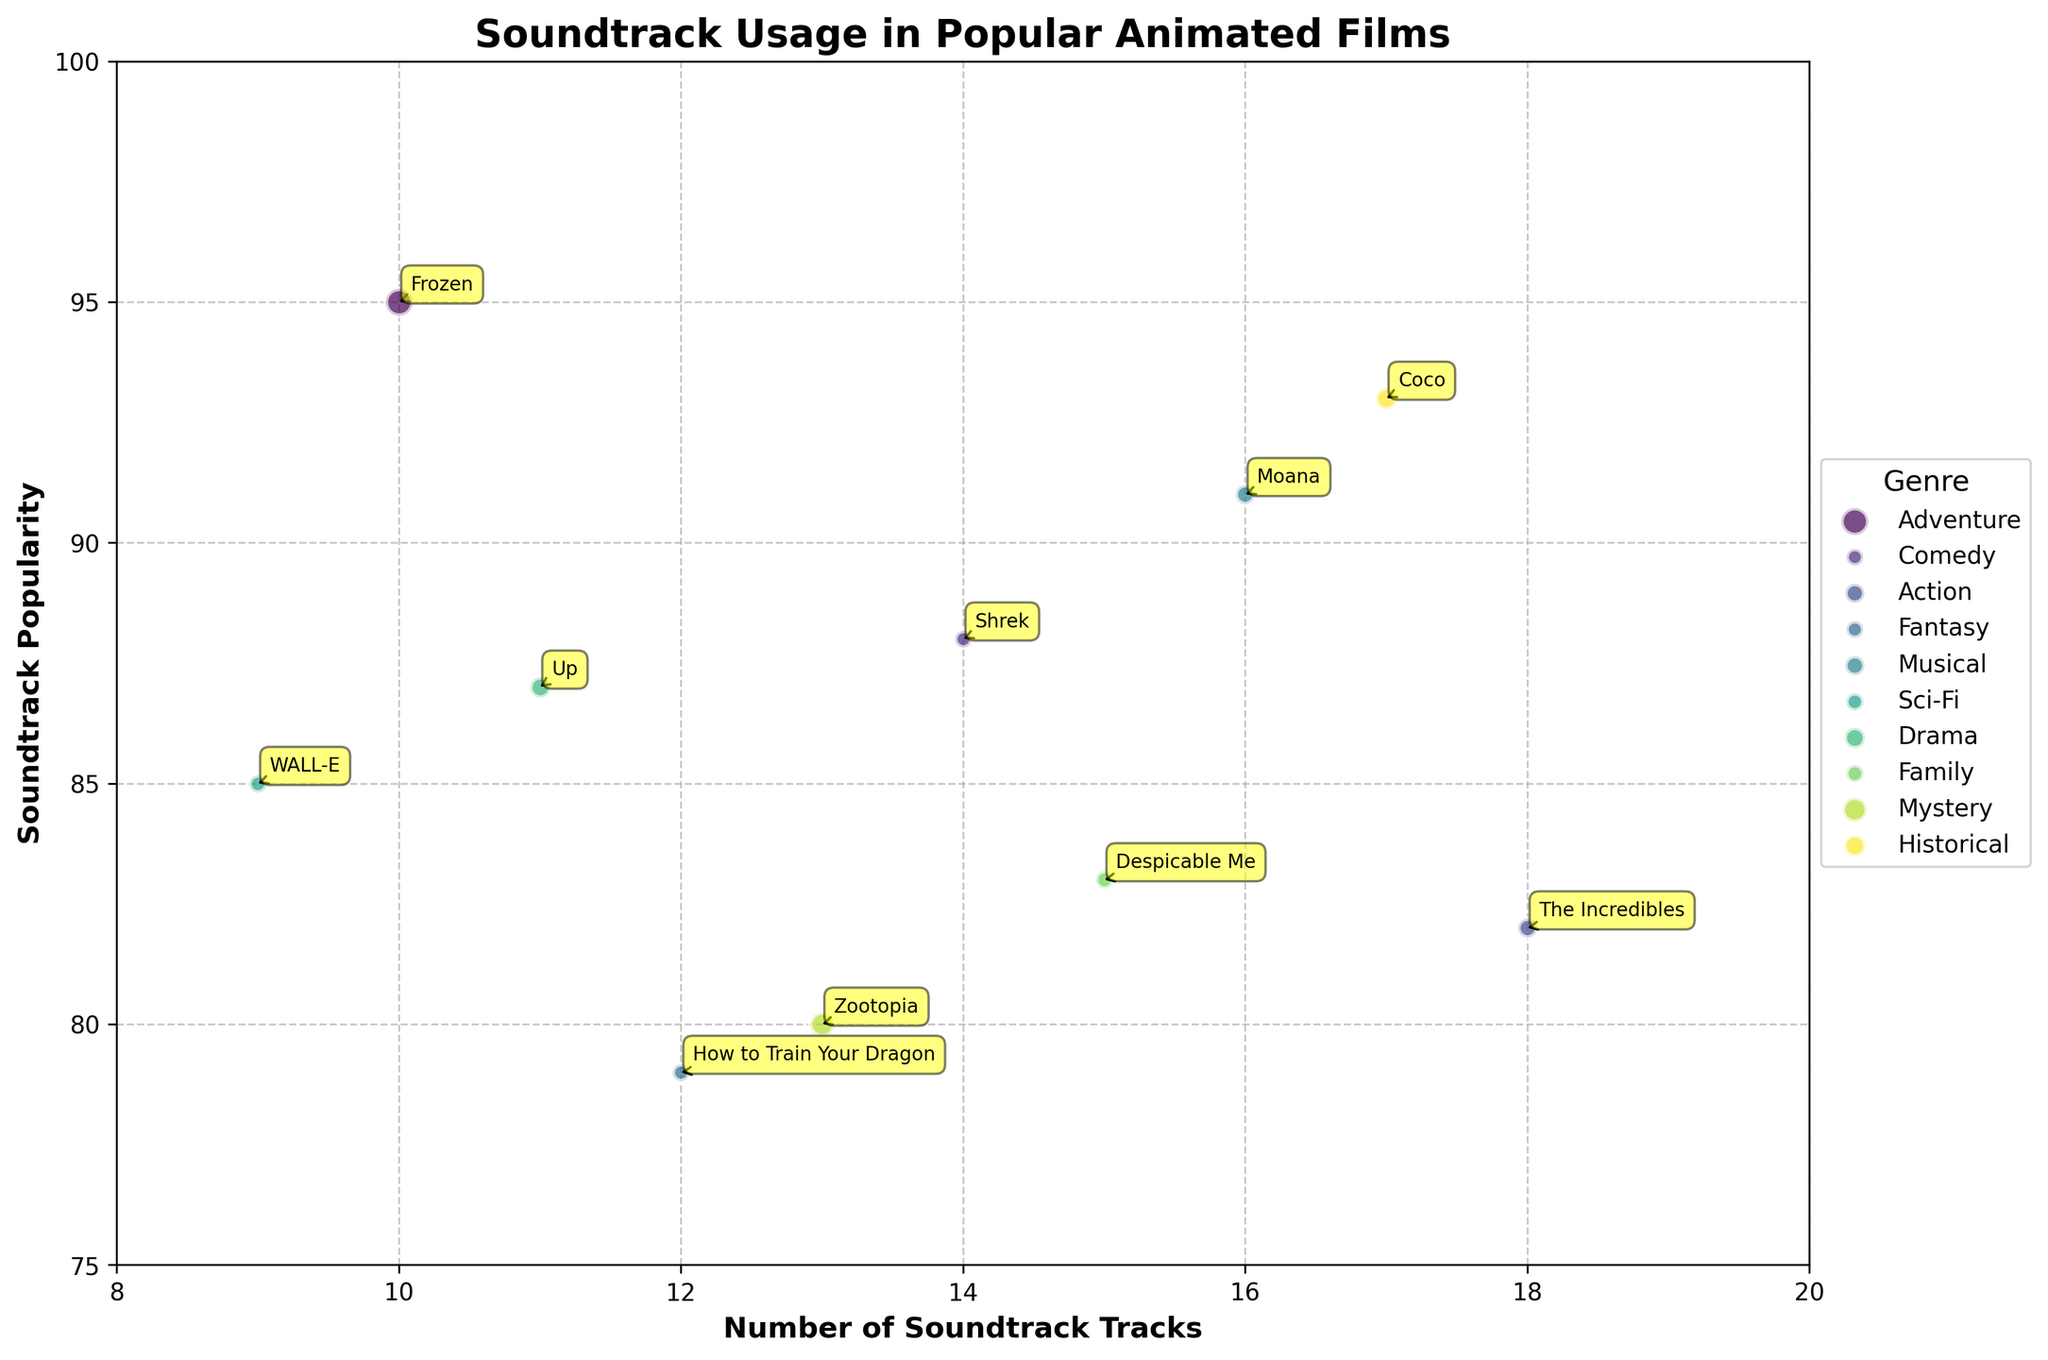What is the genre with the most number of soundtrack tracks? To determine this, look for the bubble positioned farthest to the right on the x-axis. The x-axis represents the number of soundtrack tracks. The Incredibles has the highest number, which belongs to the Action genre.
Answer: Action Which film has the highest box office performance? Evaluate the size of the bubbles, as they represent box office performance. The largest bubble is Frozen, which corresponds to a box office performance of 1280 million dollars.
Answer: Frozen How many films have a soundtrack popularity of 90 or above? Check the y-axis for bubbles positioned at or above the value of 90. The films are Frozen, Moana, and Coco, which totals to 3 films.
Answer: 3 Which film belongs to the Comedy genre, and what are its soundtrack tracks and popularity? Locate the bubble with the label "Shrek." The x-axis value shows soundtrack tracks are 14, and the y-axis value shows soundtrack popularity is 88.
Answer: Shrek, 14, 88 What is the relationship between box office performance and soundtrack popularity for Adventure and Historical genres? Compare the two bubbles labeled Frozen and Coco. Both have a high box office performance (larger bubble sizes) and high soundtrack popularity (positioned high on the y-axis). Thus, both genres perform well in both areas.
Answer: High performance in both Which genre has the least soundtrack popularity, and what is the corresponding value? Identify the lowest bubble on the y-axis. The film is How to Train Your Dragon, belonging to the Fantasy genre, with a popularity value of 79.
Answer: Fantasy, 79 Which film with more than 15 soundtrack tracks has the lowest soundtrack popularity? Look for bubbles with x-values greater than 15 and determine their y-values. The film with 18 tracks and popularity of 82 is The Incredibles.
Answer: The Incredibles What is the average box office performance of films with a soundtrack popularity above 85? Identify bubbles above y = 85; they are Frozen, Shrek, Moana, WALL-E, Up, and Coco. Sum their box office values (1280 + 484 + 643 + 521 + 735 + 807) and divide by the number of films, i.e. 6. The sum is 4470, and the average is 4470/6.
Answer: 745 How does the number of soundtrack tracks relate to soundtrack popularity for the Mystery and Family genres? Compare the two bubbles for Zootopia and Despicable Me. Zootopia (13 tracks, 80 popularity), Despicable Me (15 tracks, 83 popularity). Both have lower popularity despite having a moderate number of tracks.
Answer: Moderate tracks, lower popularity Which film has the highest soundtrack popularity besides Frozen, and what genre does it belong to? Find the second highest bubble on the y-axis. Moana follows Frozen with a popularity of 91 and belongs to the Musical genre.
Answer: Moana, Musical 